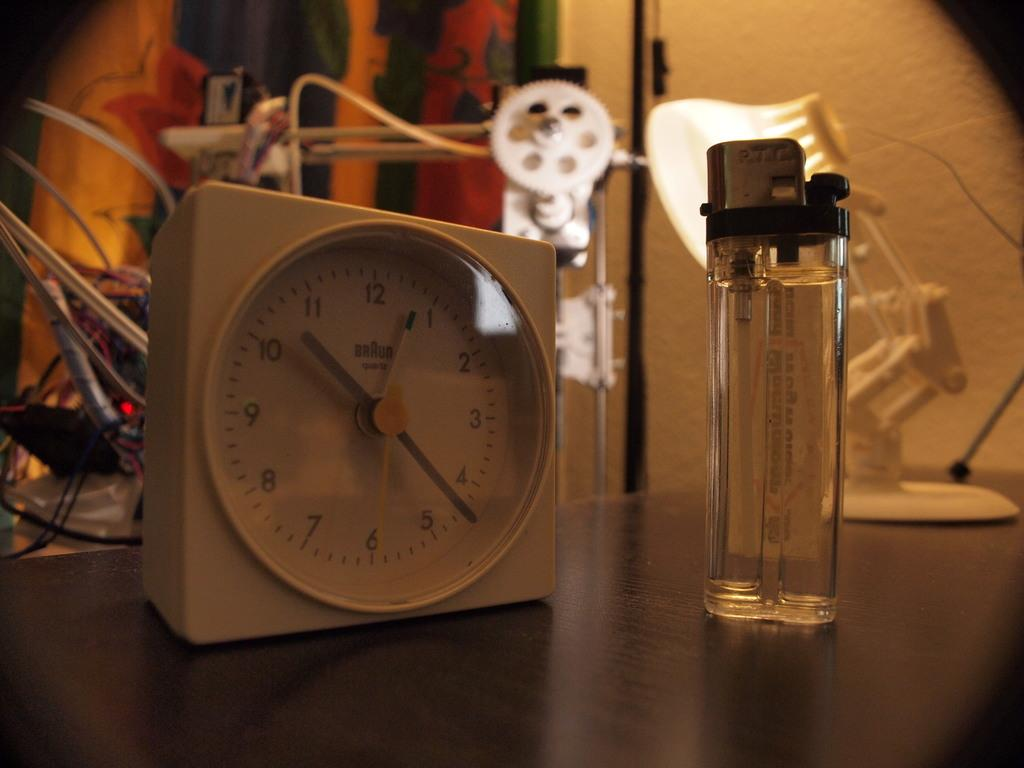<image>
Present a compact description of the photo's key features. White Braun clock next to an orange lighter. 